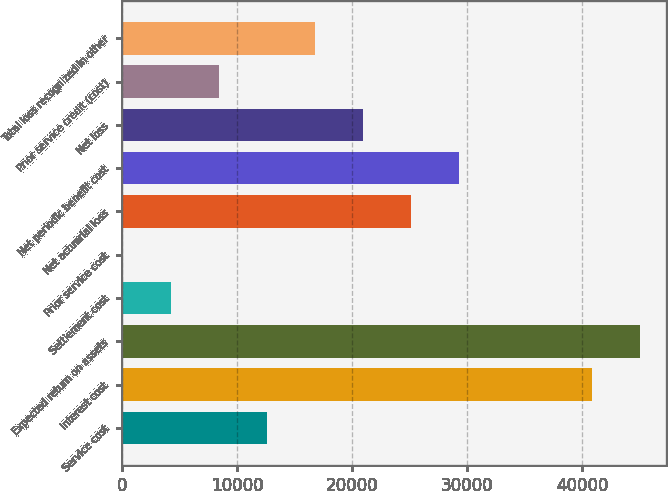Convert chart to OTSL. <chart><loc_0><loc_0><loc_500><loc_500><bar_chart><fcel>Service cost<fcel>Interest cost<fcel>Expected return on assets<fcel>Settlement cost<fcel>Prior service cost<fcel>Net actuarial loss<fcel>Net periodic benefit cost<fcel>Net loss<fcel>Prior service credit (cost)<fcel>Total loss recognized in other<nl><fcel>12540.3<fcel>40830<fcel>45007.1<fcel>4186.1<fcel>9<fcel>25071.6<fcel>29248.7<fcel>20894.5<fcel>8363.2<fcel>16717.4<nl></chart> 